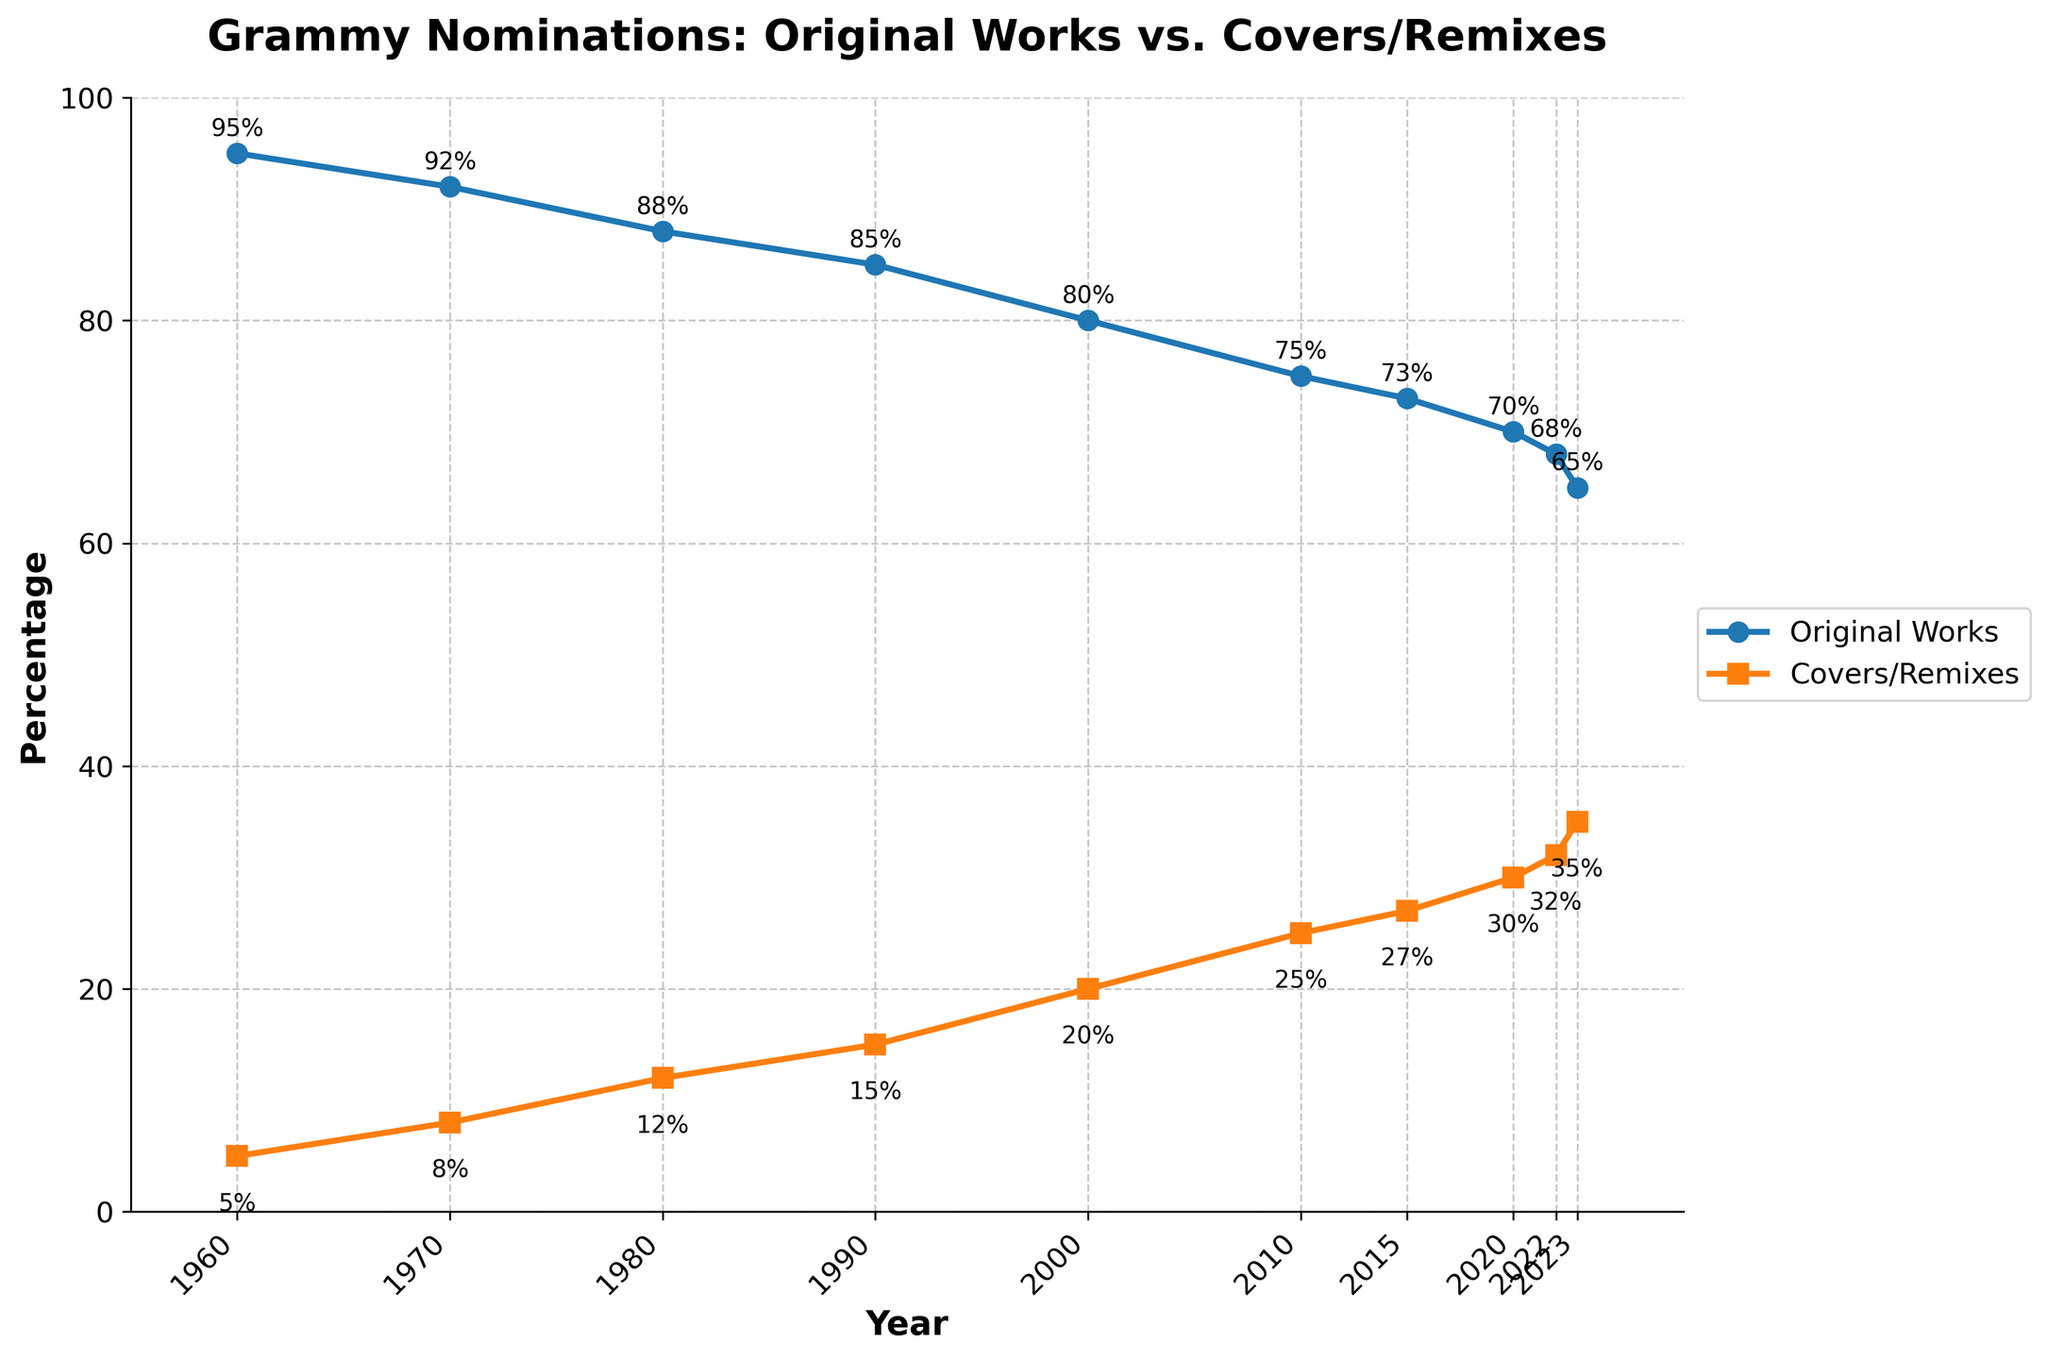What's the overall trend for the percentage of Grammy nominations for original works from 1960 to 2023? The line for original works shows a steady decline from 95% in 1960 to 65% in 2023. The trend indicates a decreasing percentage of Grammy nominations for original works over time.
Answer: Steady decline By how much did the percentage of covers/remixes increase from 1960 to 2023? In 1960, the percentage of covers/remixes was 5%, and in 2023, it was 35%. The difference is 35% - 5% = 30%.
Answer: 30% In which year did both original works and covers/remixes have the smallest difference in percentage, and what was that difference? The smallest difference between original works and covers/remixes occurred in 2023. The percentages were 65% for original works and 35% for covers/remixes, making the difference 65% - 35% = 30%.
Answer: 2023, 30% Which year had the highest percentage of Grammy nominations for covers/remixes? The highest percentage of Grammy nominations for covers/remixes occurred in 2023, with a value of 35%.
Answer: 2023 Compare the percentage of original works and covers/remixes in 1980. Which one was higher and by how much? In 1980, the percentage of original works was 88%, and covers/remixes was 12%. Original works were higher by 88% - 12% = 76%.
Answer: Original works by 76% Calculate the average percentage of original works from 1960 to 2023. The percentages for original works are 95%, 92%, 88%, 85%, 80%, 75%, 73%, 70%, 68%, and 65%. Sum these values: 95 + 92 + 88 + 85 + 80 + 75 + 73 + 70 + 68 + 65 = 791. There are 10 values, so the average is 791 / 10 = 79.1%.
Answer: 79.1% What's the visual difference between the lines representing original works and covers/remixes? The line for original works uses circular markers and is blue, while the line for covers/remixes uses square markers and is orange. The original works line is higher and declining, whereas the covers/remixes line is lower and rising.
Answer: Blue circular line higher, Orange square line lower In which decade did the percentage of original works drop below 80% for the first time? The percentage of original works dropped below 80% for the first time in the 2000s. In 2000, the percentage was 80%, and in 2010, it was 75%.
Answer: 2000s 